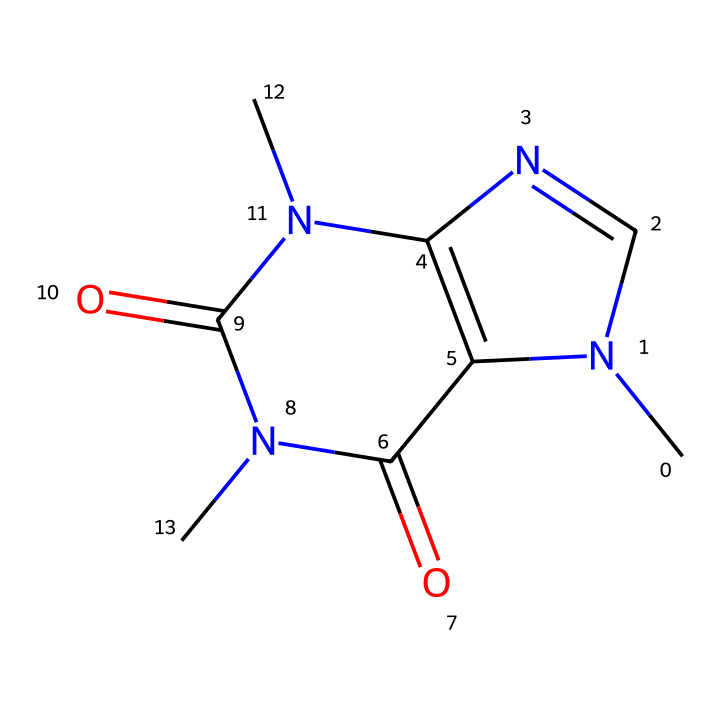What is the total number of nitrogen atoms in this molecule? By examining the SMILES representation, we can identify elements. There are two nitrogen atoms present in the structure, indicated by the letter 'N' in the SMILES.
Answer: 2 How many carbon atoms are present in the molecular structure? Looking at the SMILES sequence, we can count the number of carbon atoms, represented by 'C'. There are 8 carbon atoms in total in this chemical structure.
Answer: 8 What functional group is indicated by the presence of 'C(=O)' in the SMILES? The notation 'C(=O)' represents a carbonyl group, which is characteristic of ketones or aldehydes. In this case, it is part of the amide functional groups associated with the structure of caffeine.
Answer: carbonyl Does this molecule contain any double bonds? Observing the SMILES representation, we can see that 'C=C' indicates a double bond. The structure contains double bonds due to the presence of 'C=C' and also the carbonyl groups 'C(=O)'.
Answer: yes What is the main structural feature that classifies caffeine as a methylxanthine? The presence of nitrogen atoms in a fused ring structure is characteristic of methylxanthines. The rings and the methyl groups attached to the nitrogen atoms classify it as such.
Answer: fused rings How many oxygens are found in this molecule? The 'O' in the SMILES notation implies the presence of oxygen atoms. In this structure, there are 2 oxygen atoms shown in the carbonyl functional groups.
Answer: 2 